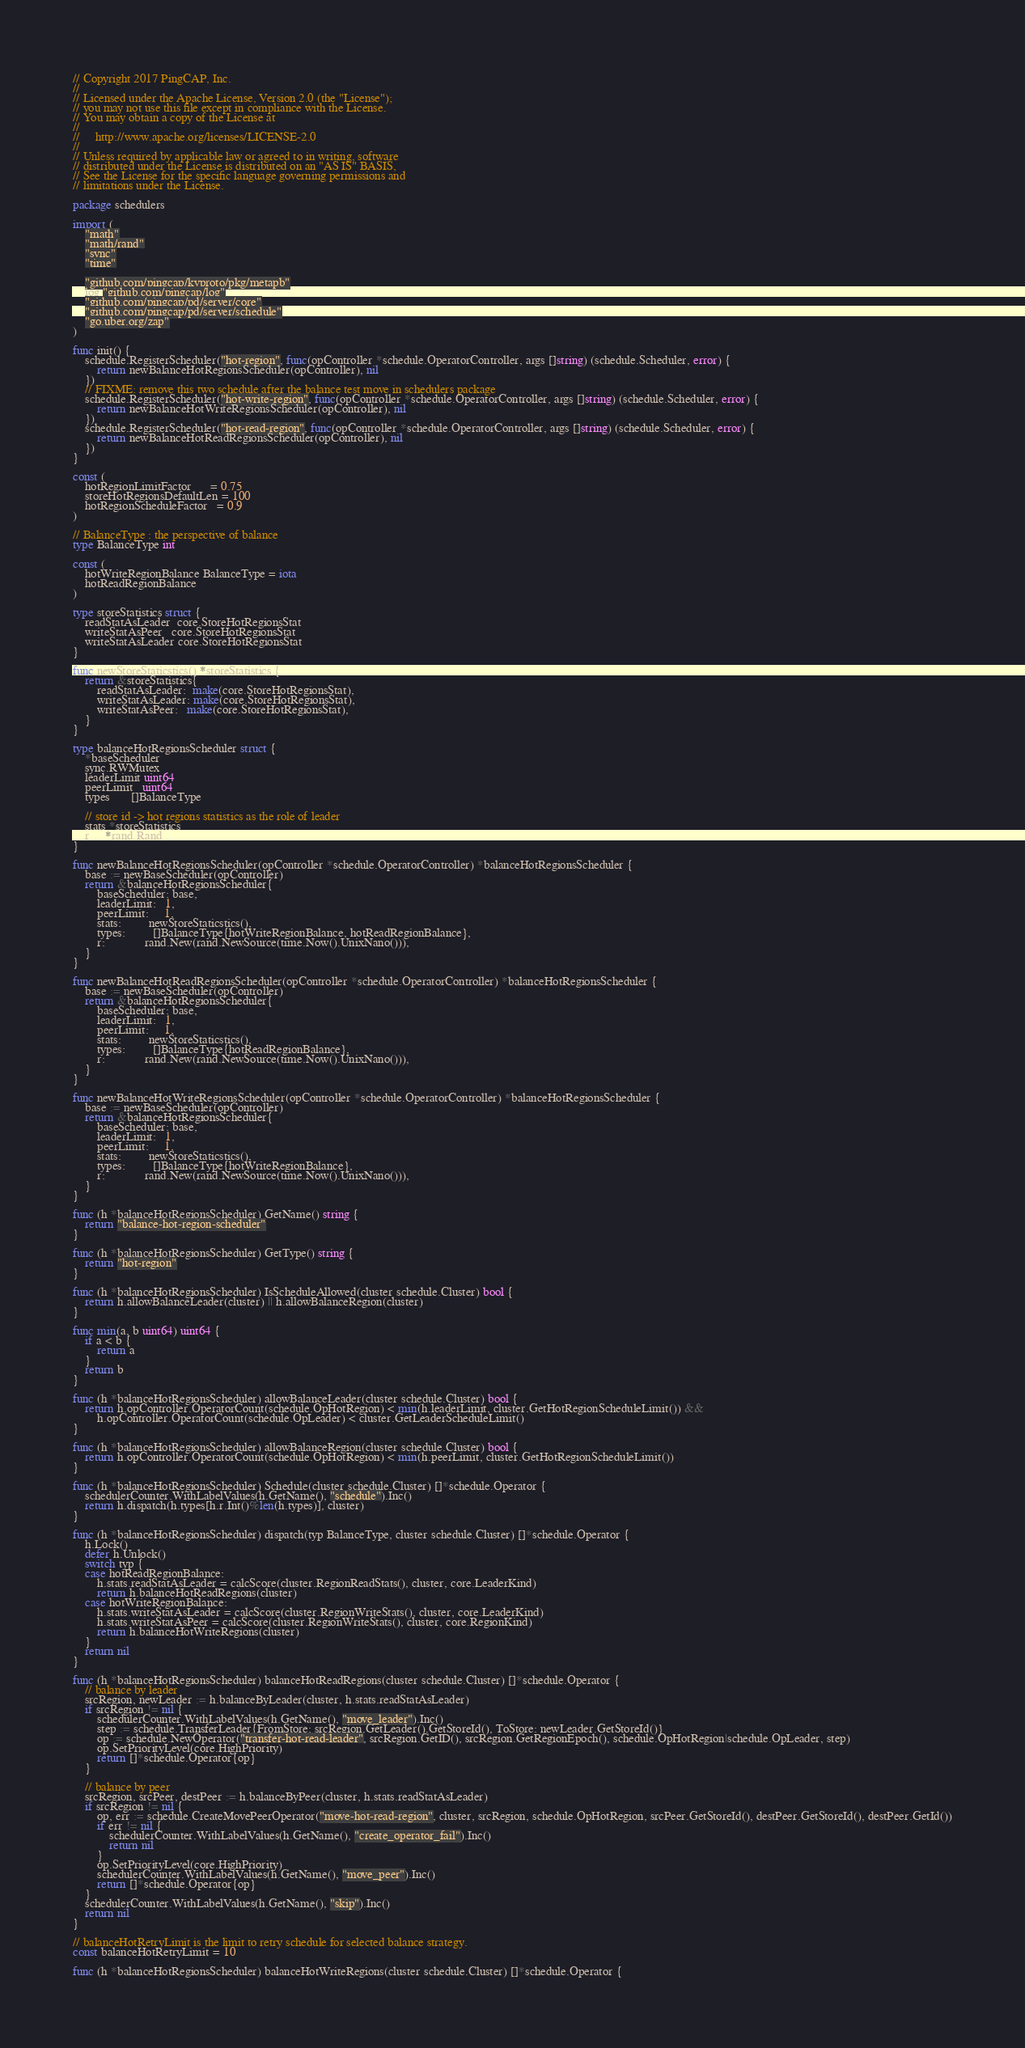Convert code to text. <code><loc_0><loc_0><loc_500><loc_500><_Go_>// Copyright 2017 PingCAP, Inc.
//
// Licensed under the Apache License, Version 2.0 (the "License");
// you may not use this file except in compliance with the License.
// You may obtain a copy of the License at
//
//     http://www.apache.org/licenses/LICENSE-2.0
//
// Unless required by applicable law or agreed to in writing, software
// distributed under the License is distributed on an "AS IS" BASIS,
// See the License for the specific language governing permissions and
// limitations under the License.

package schedulers

import (
	"math"
	"math/rand"
	"sync"
	"time"

	"github.com/pingcap/kvproto/pkg/metapb"
	log "github.com/pingcap/log"
	"github.com/pingcap/pd/server/core"
	"github.com/pingcap/pd/server/schedule"
	"go.uber.org/zap"
)

func init() {
	schedule.RegisterScheduler("hot-region", func(opController *schedule.OperatorController, args []string) (schedule.Scheduler, error) {
		return newBalanceHotRegionsScheduler(opController), nil
	})
	// FIXME: remove this two schedule after the balance test move in schedulers package
	schedule.RegisterScheduler("hot-write-region", func(opController *schedule.OperatorController, args []string) (schedule.Scheduler, error) {
		return newBalanceHotWriteRegionsScheduler(opController), nil
	})
	schedule.RegisterScheduler("hot-read-region", func(opController *schedule.OperatorController, args []string) (schedule.Scheduler, error) {
		return newBalanceHotReadRegionsScheduler(opController), nil
	})
}

const (
	hotRegionLimitFactor      = 0.75
	storeHotRegionsDefaultLen = 100
	hotRegionScheduleFactor   = 0.9
)

// BalanceType : the perspective of balance
type BalanceType int

const (
	hotWriteRegionBalance BalanceType = iota
	hotReadRegionBalance
)

type storeStatistics struct {
	readStatAsLeader  core.StoreHotRegionsStat
	writeStatAsPeer   core.StoreHotRegionsStat
	writeStatAsLeader core.StoreHotRegionsStat
}

func newStoreStaticstics() *storeStatistics {
	return &storeStatistics{
		readStatAsLeader:  make(core.StoreHotRegionsStat),
		writeStatAsLeader: make(core.StoreHotRegionsStat),
		writeStatAsPeer:   make(core.StoreHotRegionsStat),
	}
}

type balanceHotRegionsScheduler struct {
	*baseScheduler
	sync.RWMutex
	leaderLimit uint64
	peerLimit   uint64
	types       []BalanceType

	// store id -> hot regions statistics as the role of leader
	stats *storeStatistics
	r     *rand.Rand
}

func newBalanceHotRegionsScheduler(opController *schedule.OperatorController) *balanceHotRegionsScheduler {
	base := newBaseScheduler(opController)
	return &balanceHotRegionsScheduler{
		baseScheduler: base,
		leaderLimit:   1,
		peerLimit:     1,
		stats:         newStoreStaticstics(),
		types:         []BalanceType{hotWriteRegionBalance, hotReadRegionBalance},
		r:             rand.New(rand.NewSource(time.Now().UnixNano())),
	}
}

func newBalanceHotReadRegionsScheduler(opController *schedule.OperatorController) *balanceHotRegionsScheduler {
	base := newBaseScheduler(opController)
	return &balanceHotRegionsScheduler{
		baseScheduler: base,
		leaderLimit:   1,
		peerLimit:     1,
		stats:         newStoreStaticstics(),
		types:         []BalanceType{hotReadRegionBalance},
		r:             rand.New(rand.NewSource(time.Now().UnixNano())),
	}
}

func newBalanceHotWriteRegionsScheduler(opController *schedule.OperatorController) *balanceHotRegionsScheduler {
	base := newBaseScheduler(opController)
	return &balanceHotRegionsScheduler{
		baseScheduler: base,
		leaderLimit:   1,
		peerLimit:     1,
		stats:         newStoreStaticstics(),
		types:         []BalanceType{hotWriteRegionBalance},
		r:             rand.New(rand.NewSource(time.Now().UnixNano())),
	}
}

func (h *balanceHotRegionsScheduler) GetName() string {
	return "balance-hot-region-scheduler"
}

func (h *balanceHotRegionsScheduler) GetType() string {
	return "hot-region"
}

func (h *balanceHotRegionsScheduler) IsScheduleAllowed(cluster schedule.Cluster) bool {
	return h.allowBalanceLeader(cluster) || h.allowBalanceRegion(cluster)
}

func min(a, b uint64) uint64 {
	if a < b {
		return a
	}
	return b
}

func (h *balanceHotRegionsScheduler) allowBalanceLeader(cluster schedule.Cluster) bool {
	return h.opController.OperatorCount(schedule.OpHotRegion) < min(h.leaderLimit, cluster.GetHotRegionScheduleLimit()) &&
		h.opController.OperatorCount(schedule.OpLeader) < cluster.GetLeaderScheduleLimit()
}

func (h *balanceHotRegionsScheduler) allowBalanceRegion(cluster schedule.Cluster) bool {
	return h.opController.OperatorCount(schedule.OpHotRegion) < min(h.peerLimit, cluster.GetHotRegionScheduleLimit())
}

func (h *balanceHotRegionsScheduler) Schedule(cluster schedule.Cluster) []*schedule.Operator {
	schedulerCounter.WithLabelValues(h.GetName(), "schedule").Inc()
	return h.dispatch(h.types[h.r.Int()%len(h.types)], cluster)
}

func (h *balanceHotRegionsScheduler) dispatch(typ BalanceType, cluster schedule.Cluster) []*schedule.Operator {
	h.Lock()
	defer h.Unlock()
	switch typ {
	case hotReadRegionBalance:
		h.stats.readStatAsLeader = calcScore(cluster.RegionReadStats(), cluster, core.LeaderKind)
		return h.balanceHotReadRegions(cluster)
	case hotWriteRegionBalance:
		h.stats.writeStatAsLeader = calcScore(cluster.RegionWriteStats(), cluster, core.LeaderKind)
		h.stats.writeStatAsPeer = calcScore(cluster.RegionWriteStats(), cluster, core.RegionKind)
		return h.balanceHotWriteRegions(cluster)
	}
	return nil
}

func (h *balanceHotRegionsScheduler) balanceHotReadRegions(cluster schedule.Cluster) []*schedule.Operator {
	// balance by leader
	srcRegion, newLeader := h.balanceByLeader(cluster, h.stats.readStatAsLeader)
	if srcRegion != nil {
		schedulerCounter.WithLabelValues(h.GetName(), "move_leader").Inc()
		step := schedule.TransferLeader{FromStore: srcRegion.GetLeader().GetStoreId(), ToStore: newLeader.GetStoreId()}
		op := schedule.NewOperator("transfer-hot-read-leader", srcRegion.GetID(), srcRegion.GetRegionEpoch(), schedule.OpHotRegion|schedule.OpLeader, step)
		op.SetPriorityLevel(core.HighPriority)
		return []*schedule.Operator{op}
	}

	// balance by peer
	srcRegion, srcPeer, destPeer := h.balanceByPeer(cluster, h.stats.readStatAsLeader)
	if srcRegion != nil {
		op, err := schedule.CreateMovePeerOperator("move-hot-read-region", cluster, srcRegion, schedule.OpHotRegion, srcPeer.GetStoreId(), destPeer.GetStoreId(), destPeer.GetId())
		if err != nil {
			schedulerCounter.WithLabelValues(h.GetName(), "create_operator_fail").Inc()
			return nil
		}
		op.SetPriorityLevel(core.HighPriority)
		schedulerCounter.WithLabelValues(h.GetName(), "move_peer").Inc()
		return []*schedule.Operator{op}
	}
	schedulerCounter.WithLabelValues(h.GetName(), "skip").Inc()
	return nil
}

// balanceHotRetryLimit is the limit to retry schedule for selected balance strategy.
const balanceHotRetryLimit = 10

func (h *balanceHotRegionsScheduler) balanceHotWriteRegions(cluster schedule.Cluster) []*schedule.Operator {</code> 